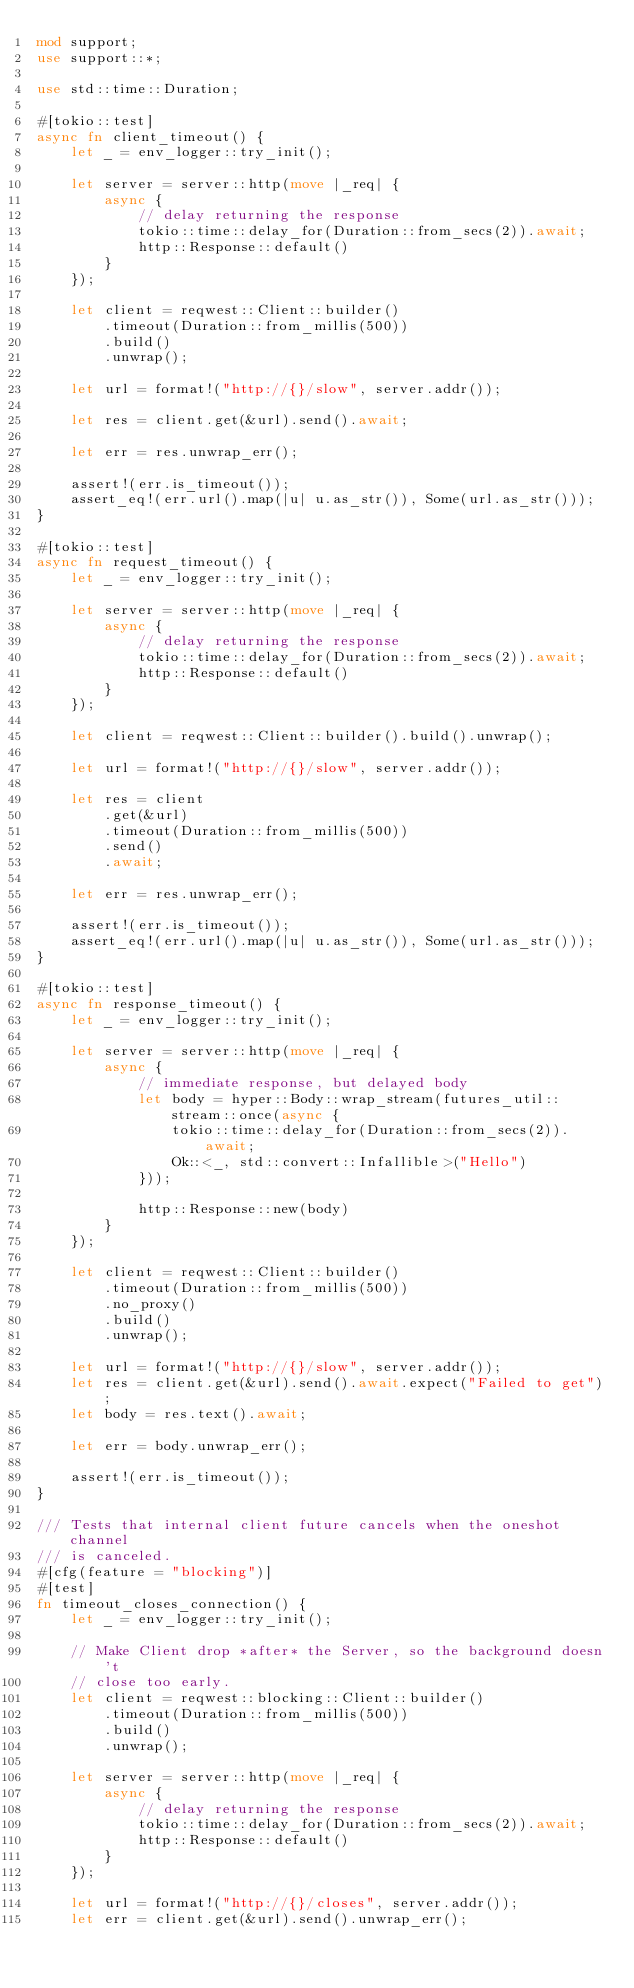<code> <loc_0><loc_0><loc_500><loc_500><_Rust_>mod support;
use support::*;

use std::time::Duration;

#[tokio::test]
async fn client_timeout() {
    let _ = env_logger::try_init();

    let server = server::http(move |_req| {
        async {
            // delay returning the response
            tokio::time::delay_for(Duration::from_secs(2)).await;
            http::Response::default()
        }
    });

    let client = reqwest::Client::builder()
        .timeout(Duration::from_millis(500))
        .build()
        .unwrap();

    let url = format!("http://{}/slow", server.addr());

    let res = client.get(&url).send().await;

    let err = res.unwrap_err();

    assert!(err.is_timeout());
    assert_eq!(err.url().map(|u| u.as_str()), Some(url.as_str()));
}

#[tokio::test]
async fn request_timeout() {
    let _ = env_logger::try_init();

    let server = server::http(move |_req| {
        async {
            // delay returning the response
            tokio::time::delay_for(Duration::from_secs(2)).await;
            http::Response::default()
        }
    });

    let client = reqwest::Client::builder().build().unwrap();

    let url = format!("http://{}/slow", server.addr());

    let res = client
        .get(&url)
        .timeout(Duration::from_millis(500))
        .send()
        .await;

    let err = res.unwrap_err();

    assert!(err.is_timeout());
    assert_eq!(err.url().map(|u| u.as_str()), Some(url.as_str()));
}

#[tokio::test]
async fn response_timeout() {
    let _ = env_logger::try_init();

    let server = server::http(move |_req| {
        async {
            // immediate response, but delayed body
            let body = hyper::Body::wrap_stream(futures_util::stream::once(async {
                tokio::time::delay_for(Duration::from_secs(2)).await;
                Ok::<_, std::convert::Infallible>("Hello")
            }));

            http::Response::new(body)
        }
    });

    let client = reqwest::Client::builder()
        .timeout(Duration::from_millis(500))
        .no_proxy()
        .build()
        .unwrap();

    let url = format!("http://{}/slow", server.addr());
    let res = client.get(&url).send().await.expect("Failed to get");
    let body = res.text().await;

    let err = body.unwrap_err();

    assert!(err.is_timeout());
}

/// Tests that internal client future cancels when the oneshot channel
/// is canceled.
#[cfg(feature = "blocking")]
#[test]
fn timeout_closes_connection() {
    let _ = env_logger::try_init();

    // Make Client drop *after* the Server, so the background doesn't
    // close too early.
    let client = reqwest::blocking::Client::builder()
        .timeout(Duration::from_millis(500))
        .build()
        .unwrap();

    let server = server::http(move |_req| {
        async {
            // delay returning the response
            tokio::time::delay_for(Duration::from_secs(2)).await;
            http::Response::default()
        }
    });

    let url = format!("http://{}/closes", server.addr());
    let err = client.get(&url).send().unwrap_err();
</code> 